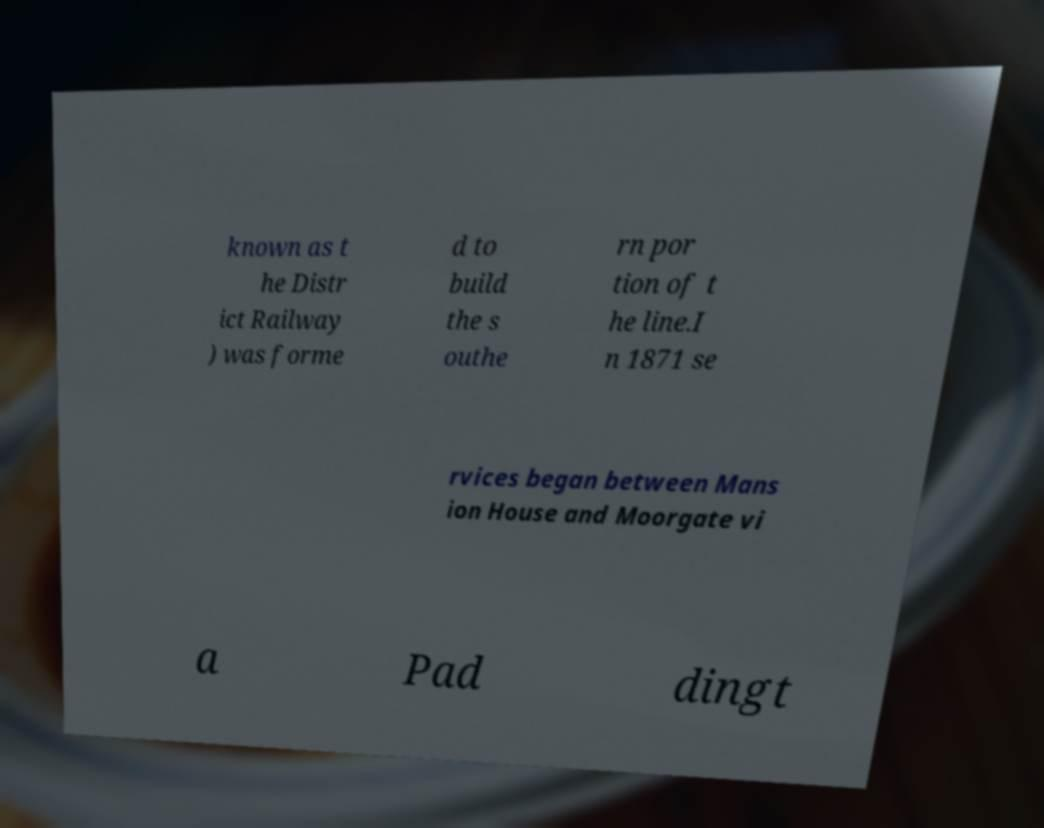What messages or text are displayed in this image? I need them in a readable, typed format. known as t he Distr ict Railway ) was forme d to build the s outhe rn por tion of t he line.I n 1871 se rvices began between Mans ion House and Moorgate vi a Pad dingt 